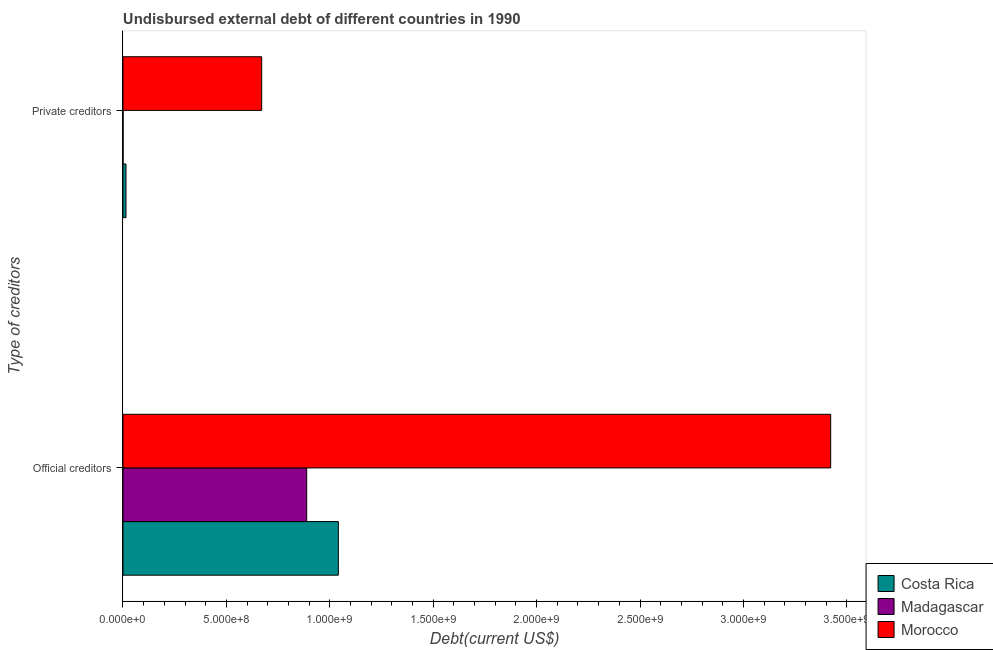Are the number of bars on each tick of the Y-axis equal?
Provide a short and direct response. Yes. What is the label of the 1st group of bars from the top?
Your answer should be very brief. Private creditors. What is the undisbursed external debt of official creditors in Costa Rica?
Keep it short and to the point. 1.04e+09. Across all countries, what is the maximum undisbursed external debt of official creditors?
Keep it short and to the point. 3.42e+09. Across all countries, what is the minimum undisbursed external debt of official creditors?
Make the answer very short. 8.88e+08. In which country was the undisbursed external debt of official creditors maximum?
Offer a very short reply. Morocco. In which country was the undisbursed external debt of official creditors minimum?
Provide a succinct answer. Madagascar. What is the total undisbursed external debt of private creditors in the graph?
Provide a short and direct response. 6.85e+08. What is the difference between the undisbursed external debt of private creditors in Madagascar and that in Morocco?
Ensure brevity in your answer.  -6.70e+08. What is the difference between the undisbursed external debt of private creditors in Costa Rica and the undisbursed external debt of official creditors in Madagascar?
Provide a short and direct response. -8.74e+08. What is the average undisbursed external debt of official creditors per country?
Offer a terse response. 1.78e+09. What is the difference between the undisbursed external debt of private creditors and undisbursed external debt of official creditors in Costa Rica?
Give a very brief answer. -1.03e+09. What is the ratio of the undisbursed external debt of private creditors in Costa Rica to that in Morocco?
Offer a very short reply. 0.02. In how many countries, is the undisbursed external debt of private creditors greater than the average undisbursed external debt of private creditors taken over all countries?
Keep it short and to the point. 1. What does the 1st bar from the top in Private creditors represents?
Offer a very short reply. Morocco. What does the 3rd bar from the bottom in Official creditors represents?
Ensure brevity in your answer.  Morocco. Are all the bars in the graph horizontal?
Offer a very short reply. Yes. Are the values on the major ticks of X-axis written in scientific E-notation?
Your response must be concise. Yes. Does the graph contain any zero values?
Make the answer very short. No. Does the graph contain grids?
Give a very brief answer. No. How many legend labels are there?
Offer a very short reply. 3. How are the legend labels stacked?
Your answer should be compact. Vertical. What is the title of the graph?
Offer a very short reply. Undisbursed external debt of different countries in 1990. What is the label or title of the X-axis?
Give a very brief answer. Debt(current US$). What is the label or title of the Y-axis?
Make the answer very short. Type of creditors. What is the Debt(current US$) of Costa Rica in Official creditors?
Make the answer very short. 1.04e+09. What is the Debt(current US$) in Madagascar in Official creditors?
Your response must be concise. 8.88e+08. What is the Debt(current US$) in Morocco in Official creditors?
Make the answer very short. 3.42e+09. What is the Debt(current US$) of Costa Rica in Private creditors?
Ensure brevity in your answer.  1.46e+07. What is the Debt(current US$) of Madagascar in Private creditors?
Make the answer very short. 2.85e+05. What is the Debt(current US$) in Morocco in Private creditors?
Keep it short and to the point. 6.71e+08. Across all Type of creditors, what is the maximum Debt(current US$) in Costa Rica?
Make the answer very short. 1.04e+09. Across all Type of creditors, what is the maximum Debt(current US$) of Madagascar?
Offer a very short reply. 8.88e+08. Across all Type of creditors, what is the maximum Debt(current US$) in Morocco?
Your answer should be very brief. 3.42e+09. Across all Type of creditors, what is the minimum Debt(current US$) in Costa Rica?
Keep it short and to the point. 1.46e+07. Across all Type of creditors, what is the minimum Debt(current US$) of Madagascar?
Provide a succinct answer. 2.85e+05. Across all Type of creditors, what is the minimum Debt(current US$) in Morocco?
Keep it short and to the point. 6.71e+08. What is the total Debt(current US$) of Costa Rica in the graph?
Your answer should be very brief. 1.06e+09. What is the total Debt(current US$) in Madagascar in the graph?
Make the answer very short. 8.89e+08. What is the total Debt(current US$) of Morocco in the graph?
Offer a very short reply. 4.09e+09. What is the difference between the Debt(current US$) in Costa Rica in Official creditors and that in Private creditors?
Your answer should be compact. 1.03e+09. What is the difference between the Debt(current US$) in Madagascar in Official creditors and that in Private creditors?
Provide a short and direct response. 8.88e+08. What is the difference between the Debt(current US$) in Morocco in Official creditors and that in Private creditors?
Your answer should be very brief. 2.75e+09. What is the difference between the Debt(current US$) in Costa Rica in Official creditors and the Debt(current US$) in Madagascar in Private creditors?
Make the answer very short. 1.04e+09. What is the difference between the Debt(current US$) in Costa Rica in Official creditors and the Debt(current US$) in Morocco in Private creditors?
Offer a terse response. 3.71e+08. What is the difference between the Debt(current US$) of Madagascar in Official creditors and the Debt(current US$) of Morocco in Private creditors?
Keep it short and to the point. 2.18e+08. What is the average Debt(current US$) of Costa Rica per Type of creditors?
Keep it short and to the point. 5.28e+08. What is the average Debt(current US$) in Madagascar per Type of creditors?
Keep it short and to the point. 4.44e+08. What is the average Debt(current US$) in Morocco per Type of creditors?
Provide a succinct answer. 2.05e+09. What is the difference between the Debt(current US$) of Costa Rica and Debt(current US$) of Madagascar in Official creditors?
Your response must be concise. 1.53e+08. What is the difference between the Debt(current US$) of Costa Rica and Debt(current US$) of Morocco in Official creditors?
Keep it short and to the point. -2.38e+09. What is the difference between the Debt(current US$) in Madagascar and Debt(current US$) in Morocco in Official creditors?
Keep it short and to the point. -2.53e+09. What is the difference between the Debt(current US$) of Costa Rica and Debt(current US$) of Madagascar in Private creditors?
Give a very brief answer. 1.43e+07. What is the difference between the Debt(current US$) in Costa Rica and Debt(current US$) in Morocco in Private creditors?
Offer a very short reply. -6.56e+08. What is the difference between the Debt(current US$) of Madagascar and Debt(current US$) of Morocco in Private creditors?
Give a very brief answer. -6.70e+08. What is the ratio of the Debt(current US$) in Costa Rica in Official creditors to that in Private creditors?
Your response must be concise. 71.49. What is the ratio of the Debt(current US$) in Madagascar in Official creditors to that in Private creditors?
Your answer should be very brief. 3116.75. What is the ratio of the Debt(current US$) of Morocco in Official creditors to that in Private creditors?
Your response must be concise. 5.1. What is the difference between the highest and the second highest Debt(current US$) in Costa Rica?
Provide a short and direct response. 1.03e+09. What is the difference between the highest and the second highest Debt(current US$) in Madagascar?
Ensure brevity in your answer.  8.88e+08. What is the difference between the highest and the second highest Debt(current US$) in Morocco?
Offer a very short reply. 2.75e+09. What is the difference between the highest and the lowest Debt(current US$) in Costa Rica?
Your answer should be very brief. 1.03e+09. What is the difference between the highest and the lowest Debt(current US$) in Madagascar?
Your answer should be very brief. 8.88e+08. What is the difference between the highest and the lowest Debt(current US$) in Morocco?
Make the answer very short. 2.75e+09. 